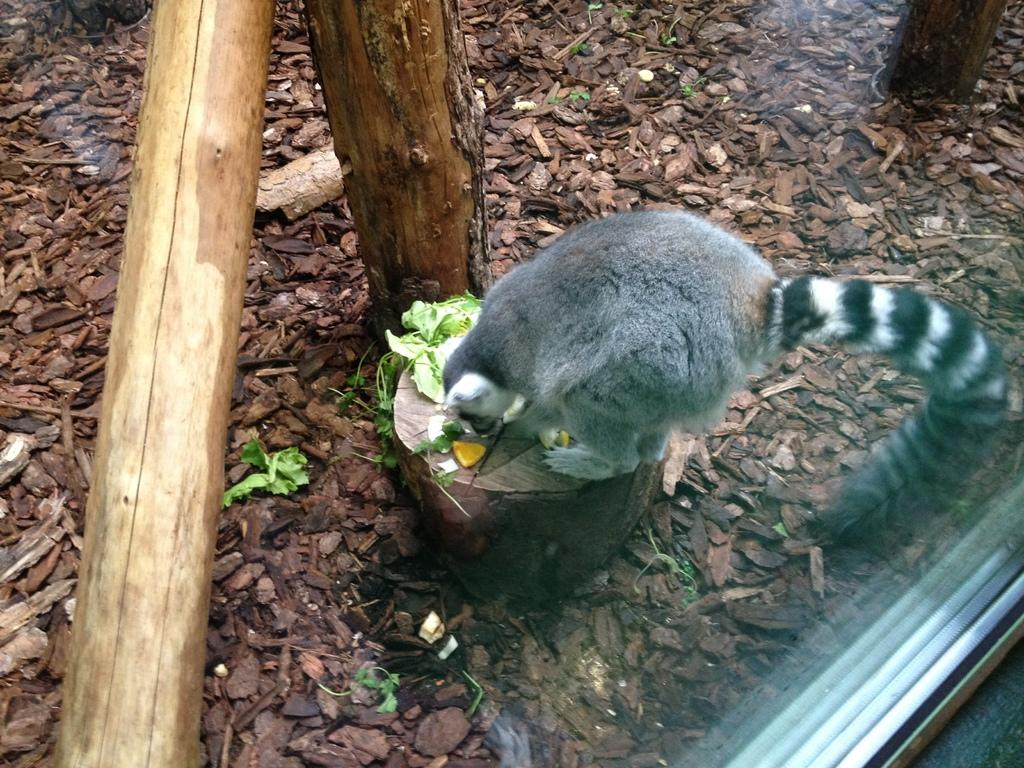What is the main subject of the image? There is a cat in the center of the image. What can be seen in the background of the image? There are bark pieces in the background of the image. What is located on the left side of the image? Wood logs are present on the left side of the image. What type of kettle is being used to shake the sticks in the image? There is no kettle or sticks present in the image. 